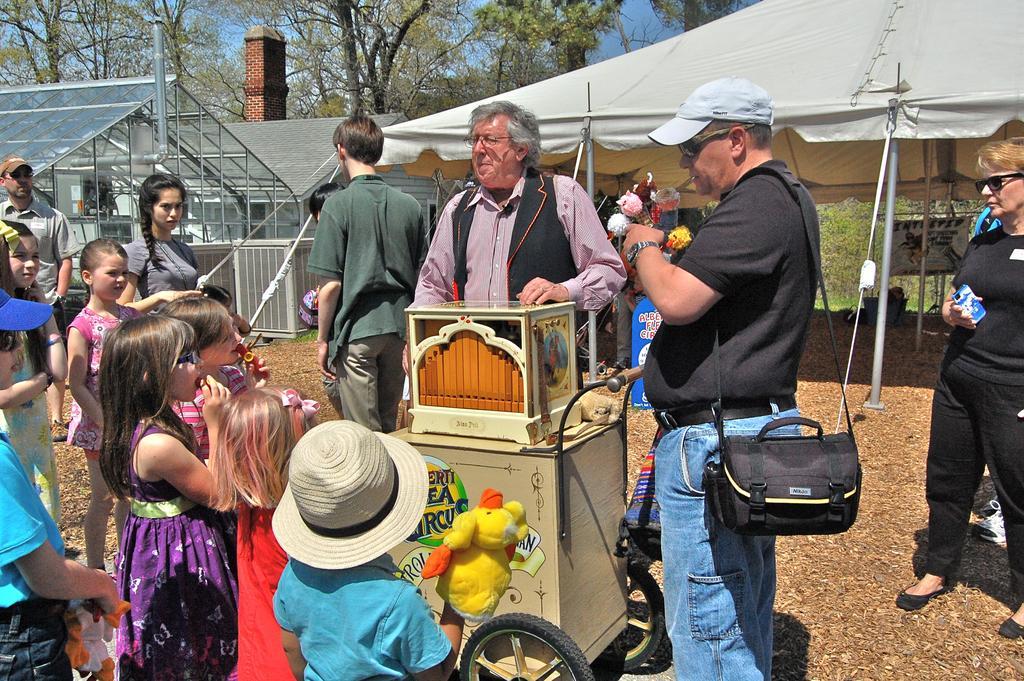In one or two sentences, can you explain what this image depicts? In the foreground the picture of there are kids, people, cart and waste on the ground. In the center of the picture there is a house and there is a tent. In the background there are trees. Sky is sunny. 